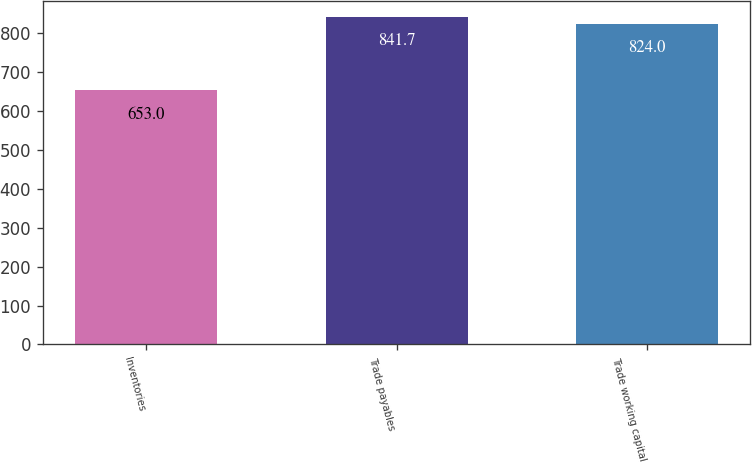Convert chart to OTSL. <chart><loc_0><loc_0><loc_500><loc_500><bar_chart><fcel>Inventories<fcel>Trade payables<fcel>Trade working capital<nl><fcel>653<fcel>841.7<fcel>824<nl></chart> 